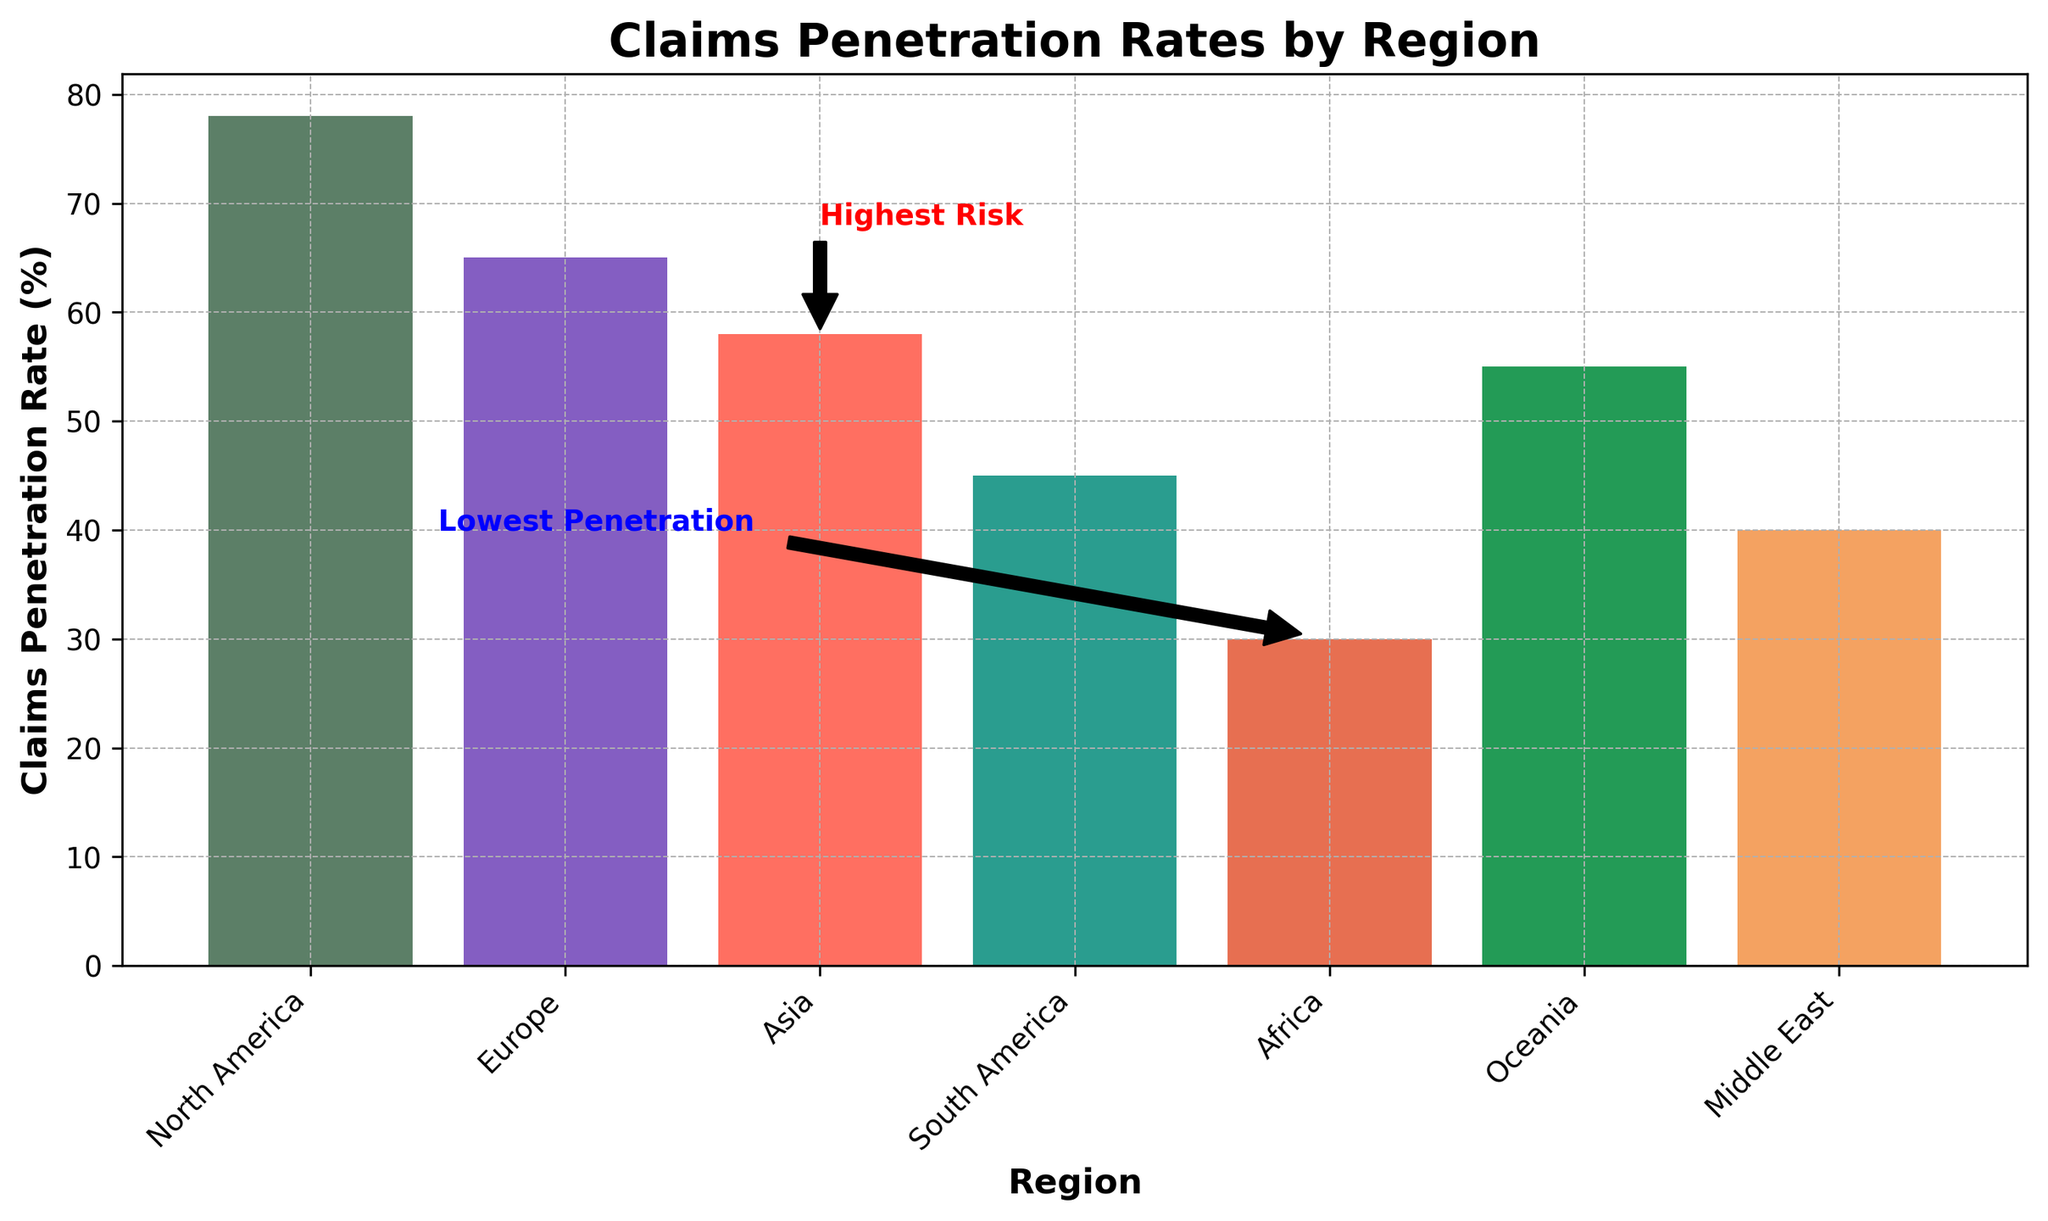What is the Claims Penetration Rate for Europe? The figure shows a bar chart with the Claims Penetration Rates labeled for each region. From the chart, locate the bar for Europe.
Answer: 65 Which region has the highest Claims Penetration Rate? Check the bar chart and identify the region with the tallest bar, which represents the highest Claims Penetration Rate.
Answer: North America What is the difference in Claims Penetration Rate between Asia and South America? Locate the bars corresponding to Asia and South America and find their respective Claims Penetration Rates from the y-axis. Subtract the rate of South America from the rate of Asia (58 - 45).
Answer: 13 What do the annotations 'Highest Risk' and 'Lowest Penetration' refer to? Identify the annotations on the figure. 'Highest Risk' is marked next to the Asia bar, and 'Lowest Penetration' is marked near the Africa bar.
Answer: Asia and Africa Which regions are marked with a high risk level? The data bar chart provides risk levels for the regions. Identify the regions with the 'High' risk level annotation next to their respective bars.
Answer: Asia, South America, Middle East How does the Claims Penetration Rate of Oceania compare to that of Europe? Find the Claims Penetration Rates for both regions on the chart. Compare the height of the bars: Oceania has a rate of 55, and Europe has a rate of 65.
Answer: Oceania has a lower rate than Europe What is the median Claims Penetration Rate among all regions? Arrange the Claims Penetration Rates in ascending order: 30, 40, 45, 55, 58, 65, 78. The median is the middle value, which is the 4th value (55).
Answer: 55 Which region has the lowest Claims Penetration Rate and what is the Compliance Note associated with it? Identify the shortest bar in the chart (Africa) and read the corresponding Compliance Note in the data.
Answer: Africa, "Check for updates on local compliance rules" What is the total Claims Penetration Rate across all regions? Sum the Claims Penetration Rates for all regions: 78 (North America) + 65 (Europe) + 58 (Asia) + 45 (South America) + 30 (Africa) + 55 (Oceania) + 40 (Middle East) = 371.
Answer: 371 In which region is the Claims Penetration Rate closest to the average value across all regions? Calculate the average value by dividing the total Claims Penetration Rate by the number of regions (371/7 ≈ 53). Identify the region with a rate closest to this value. Oceania has a rate of 55, which is closest.
Answer: Oceania 